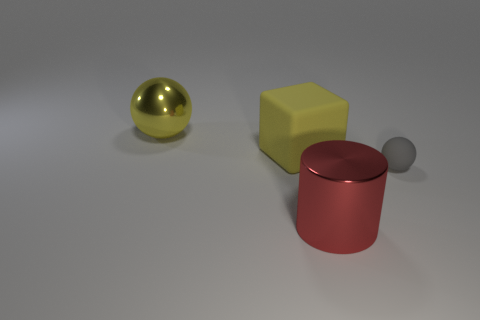What shape is the other object that is the same color as the large rubber thing?
Keep it short and to the point. Sphere. How many yellow things are either metal balls or blocks?
Provide a succinct answer. 2. There is a matte object that is the same color as the big sphere; what size is it?
Give a very brief answer. Large. What number of tiny rubber spheres are behind the gray thing?
Ensure brevity in your answer.  0. There is a rubber thing on the left side of the sphere to the right of the sphere that is on the left side of the yellow matte block; what size is it?
Your answer should be very brief. Large. There is a metallic thing that is to the left of the big thing in front of the big matte block; is there a yellow metallic thing to the left of it?
Your answer should be compact. No. Is the number of objects greater than the number of big green blocks?
Your answer should be compact. Yes. There is a metal thing in front of the large yellow metal object; what color is it?
Make the answer very short. Red. Are there more large metal cylinders that are left of the large yellow sphere than small green objects?
Offer a very short reply. No. Is the material of the large red cylinder the same as the yellow cube?
Your response must be concise. No. 